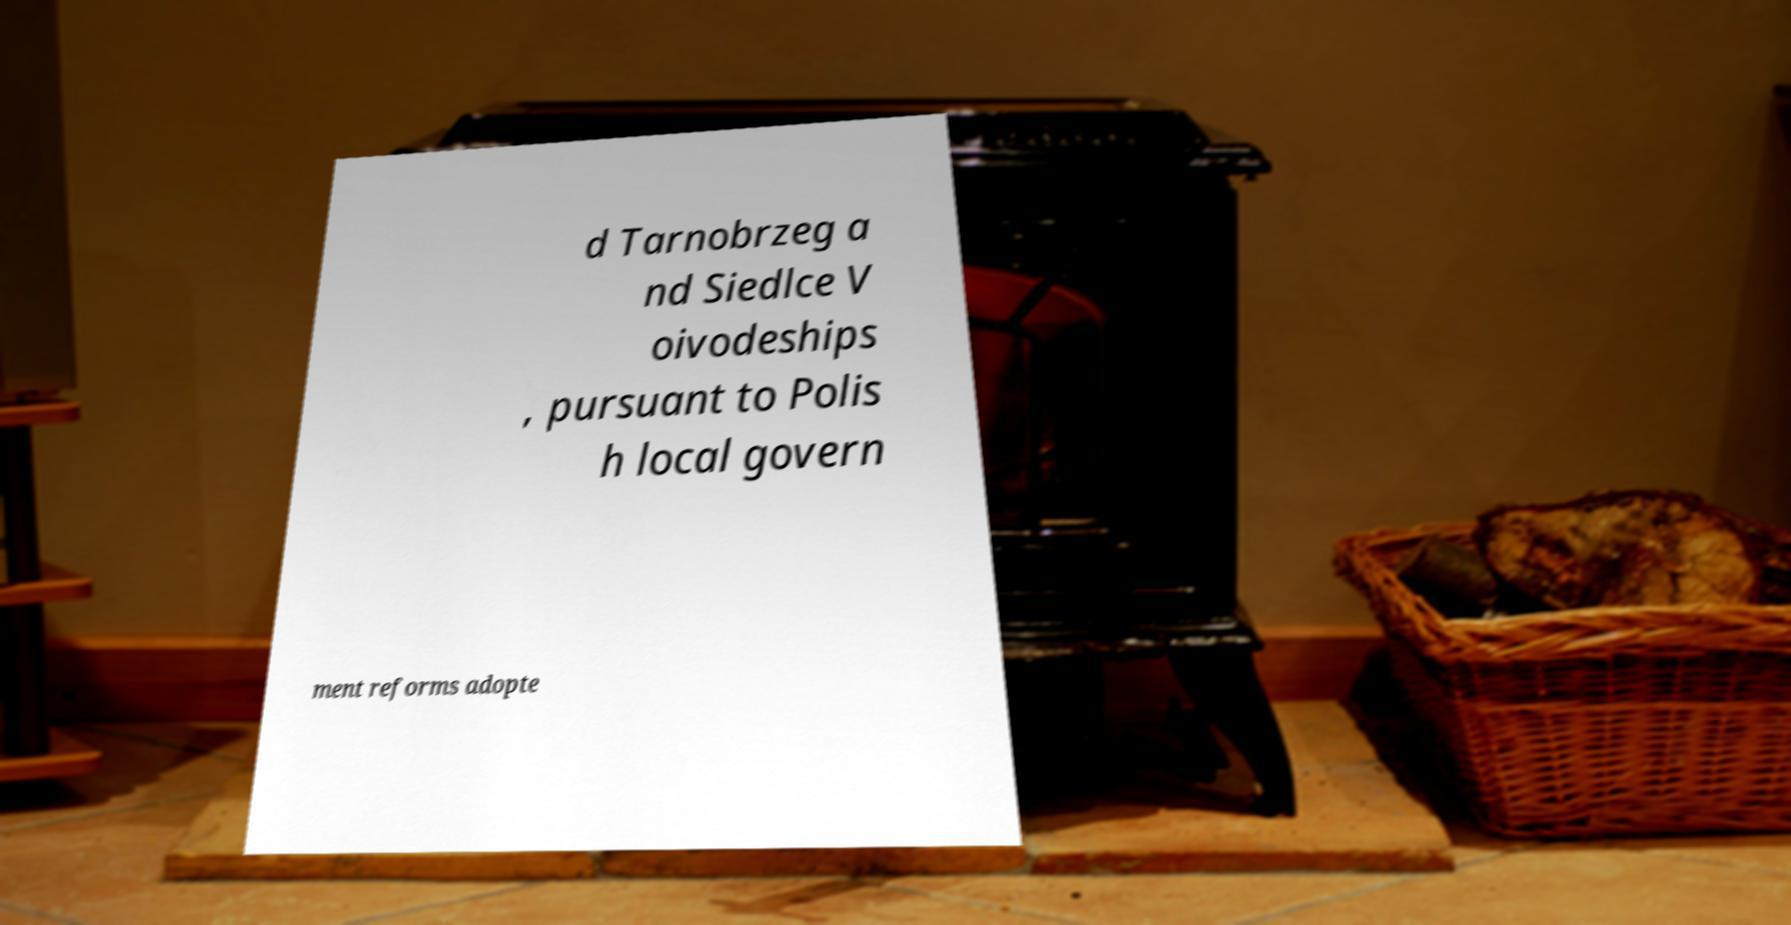What messages or text are displayed in this image? I need them in a readable, typed format. d Tarnobrzeg a nd Siedlce V oivodeships , pursuant to Polis h local govern ment reforms adopte 